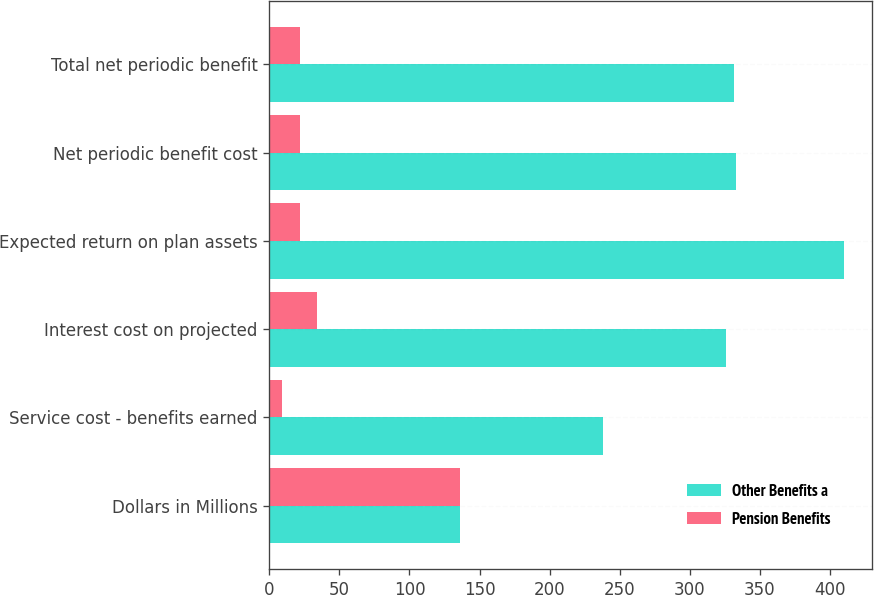Convert chart to OTSL. <chart><loc_0><loc_0><loc_500><loc_500><stacked_bar_chart><ecel><fcel>Dollars in Millions<fcel>Service cost - benefits earned<fcel>Interest cost on projected<fcel>Expected return on plan assets<fcel>Net periodic benefit cost<fcel>Total net periodic benefit<nl><fcel>Other Benefits a<fcel>136<fcel>238<fcel>326<fcel>410<fcel>333<fcel>332<nl><fcel>Pension Benefits<fcel>136<fcel>9<fcel>34<fcel>22<fcel>22<fcel>22<nl></chart> 